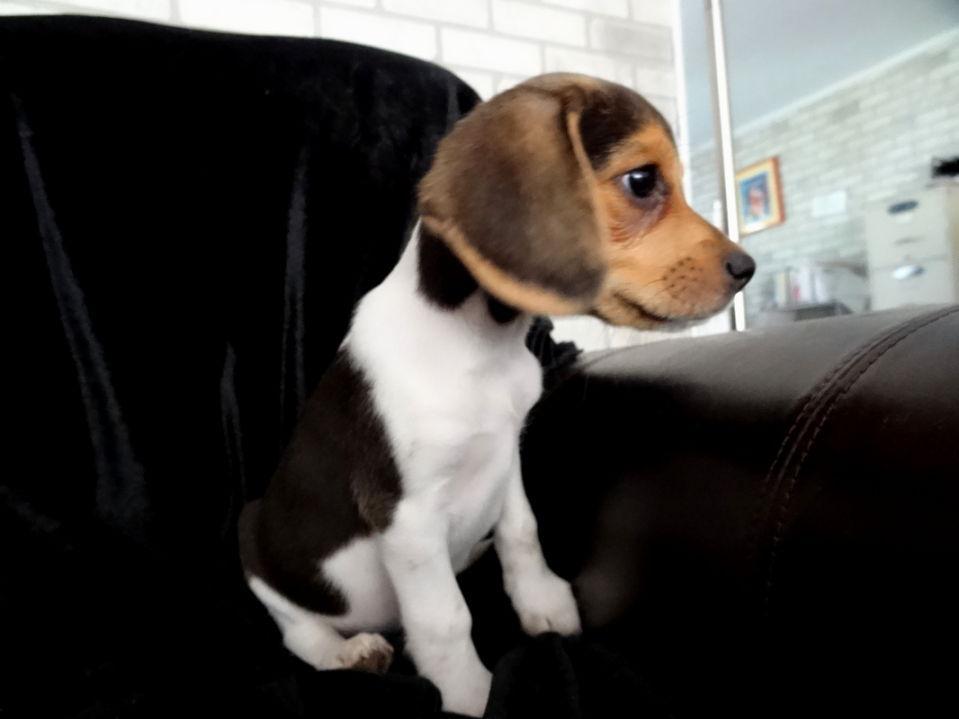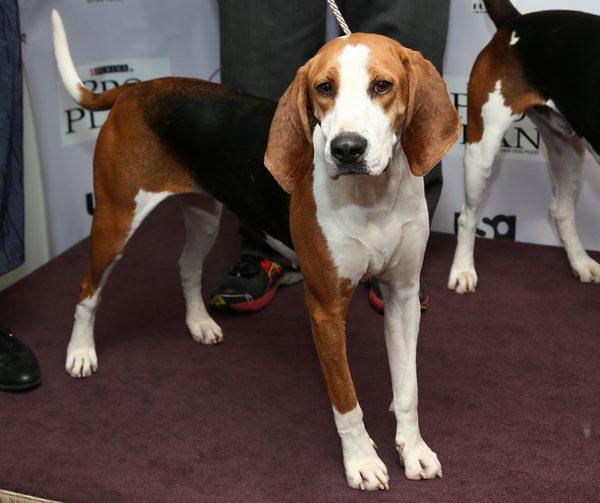The first image is the image on the left, the second image is the image on the right. Considering the images on both sides, is "At least one dog is sitting." valid? Answer yes or no. Yes. 